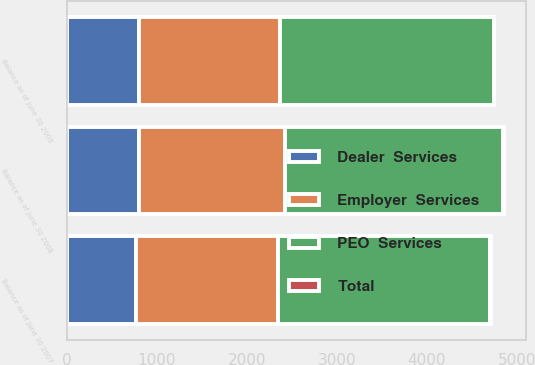Convert chart. <chart><loc_0><loc_0><loc_500><loc_500><stacked_bar_chart><ecel><fcel>Balance as of June 30 2007<fcel>Balance as of June 30 2008<fcel>Balance as of June 30 2009<nl><fcel>Employer  Services<fcel>1576.6<fcel>1615.7<fcel>1567<nl><fcel>Total<fcel>4.8<fcel>4.8<fcel>4.8<nl><fcel>Dealer  Services<fcel>772.2<fcel>806.2<fcel>803.7<nl><fcel>PEO  Services<fcel>2353.6<fcel>2426.7<fcel>2375.5<nl></chart> 